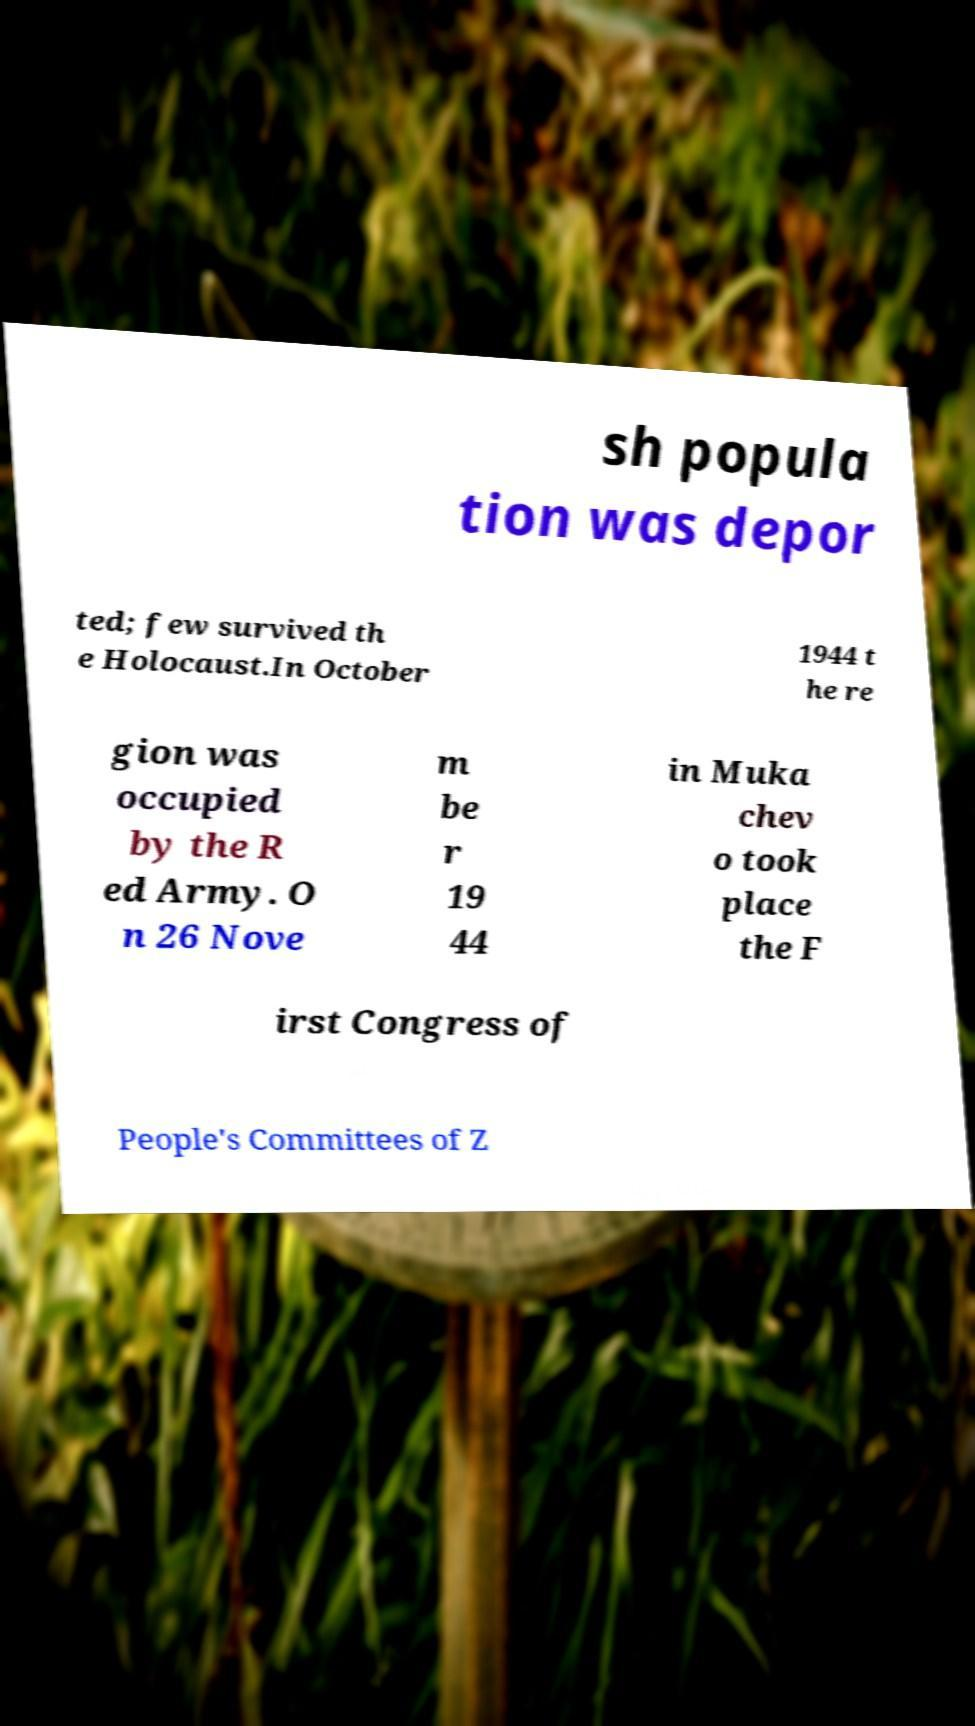What messages or text are displayed in this image? I need them in a readable, typed format. sh popula tion was depor ted; few survived th e Holocaust.In October 1944 t he re gion was occupied by the R ed Army. O n 26 Nove m be r 19 44 in Muka chev o took place the F irst Congress of People's Committees of Z 